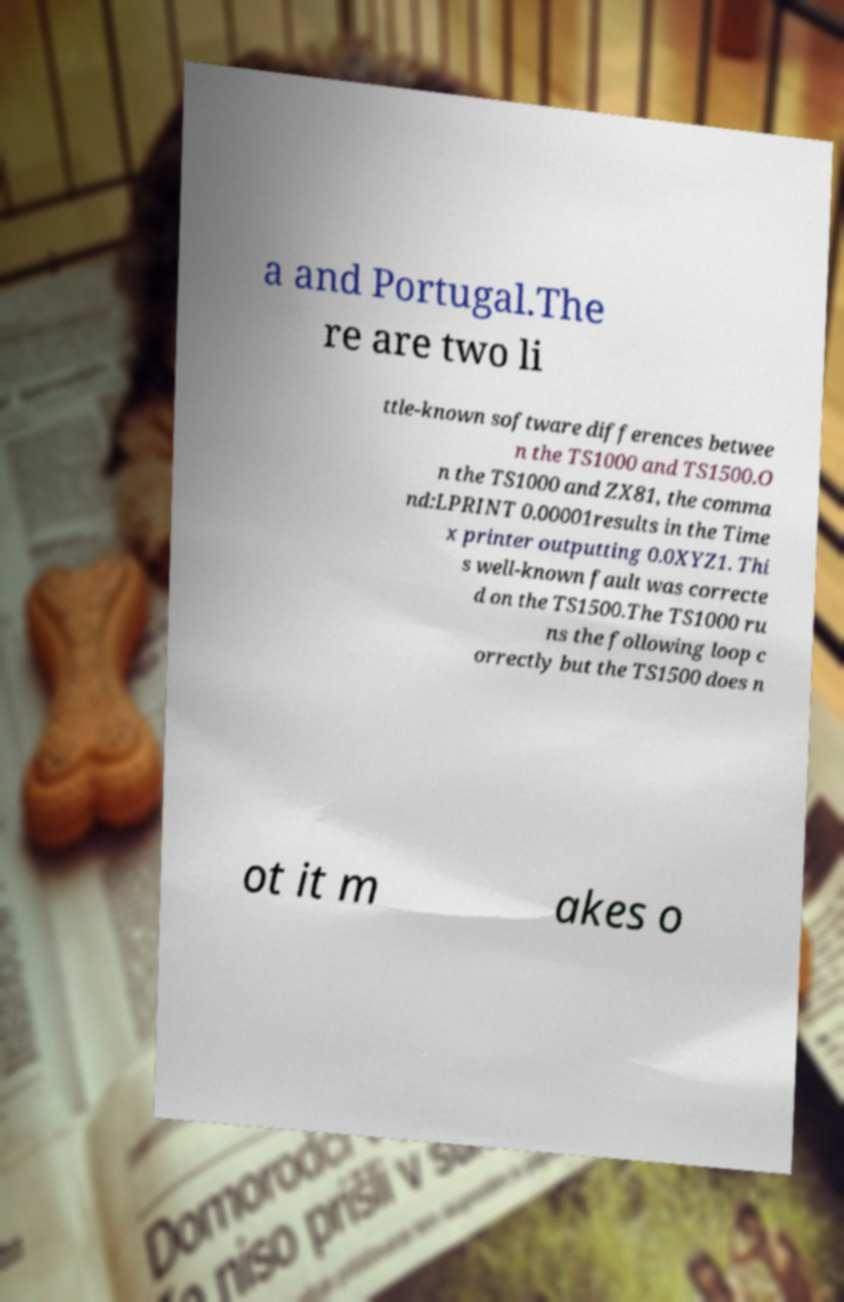Please identify and transcribe the text found in this image. a and Portugal.The re are two li ttle-known software differences betwee n the TS1000 and TS1500.O n the TS1000 and ZX81, the comma nd:LPRINT 0.00001results in the Time x printer outputting 0.0XYZ1. Thi s well-known fault was correcte d on the TS1500.The TS1000 ru ns the following loop c orrectly but the TS1500 does n ot it m akes o 